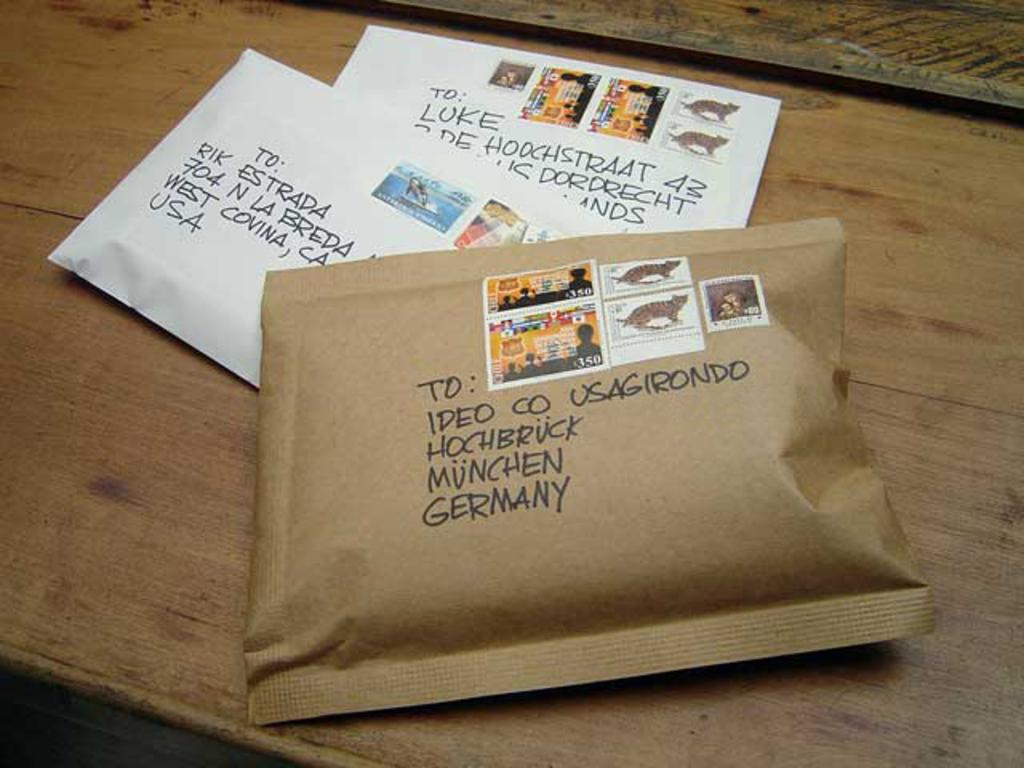<image>
Write a terse but informative summary of the picture. Two white and one brown large padded envelopes, the brown one in front labeled Munchen Germany 